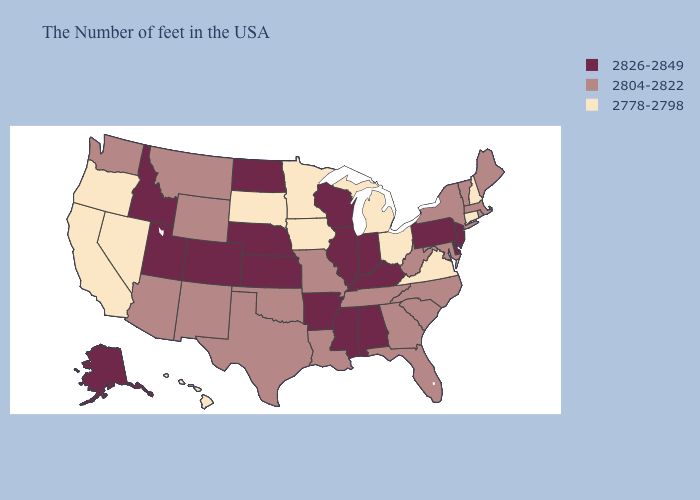What is the value of Oklahoma?
Concise answer only. 2804-2822. Name the states that have a value in the range 2826-2849?
Short answer required. New Jersey, Delaware, Pennsylvania, Kentucky, Indiana, Alabama, Wisconsin, Illinois, Mississippi, Arkansas, Kansas, Nebraska, North Dakota, Colorado, Utah, Idaho, Alaska. Does Iowa have a lower value than New Mexico?
Concise answer only. Yes. Does Michigan have the lowest value in the MidWest?
Answer briefly. Yes. Name the states that have a value in the range 2826-2849?
Write a very short answer. New Jersey, Delaware, Pennsylvania, Kentucky, Indiana, Alabama, Wisconsin, Illinois, Mississippi, Arkansas, Kansas, Nebraska, North Dakota, Colorado, Utah, Idaho, Alaska. Among the states that border Kansas , which have the lowest value?
Keep it brief. Missouri, Oklahoma. Does Louisiana have a higher value than Oklahoma?
Answer briefly. No. What is the value of Ohio?
Give a very brief answer. 2778-2798. Does Oregon have the same value as Virginia?
Quick response, please. Yes. What is the value of West Virginia?
Short answer required. 2804-2822. What is the value of Illinois?
Quick response, please. 2826-2849. Does New York have a lower value than Florida?
Be succinct. No. What is the lowest value in states that border Missouri?
Answer briefly. 2778-2798. Among the states that border South Dakota , does Wyoming have the lowest value?
Answer briefly. No. Name the states that have a value in the range 2804-2822?
Short answer required. Maine, Massachusetts, Rhode Island, Vermont, New York, Maryland, North Carolina, South Carolina, West Virginia, Florida, Georgia, Tennessee, Louisiana, Missouri, Oklahoma, Texas, Wyoming, New Mexico, Montana, Arizona, Washington. 